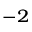Convert formula to latex. <formula><loc_0><loc_0><loc_500><loc_500>^ { - 2 }</formula> 